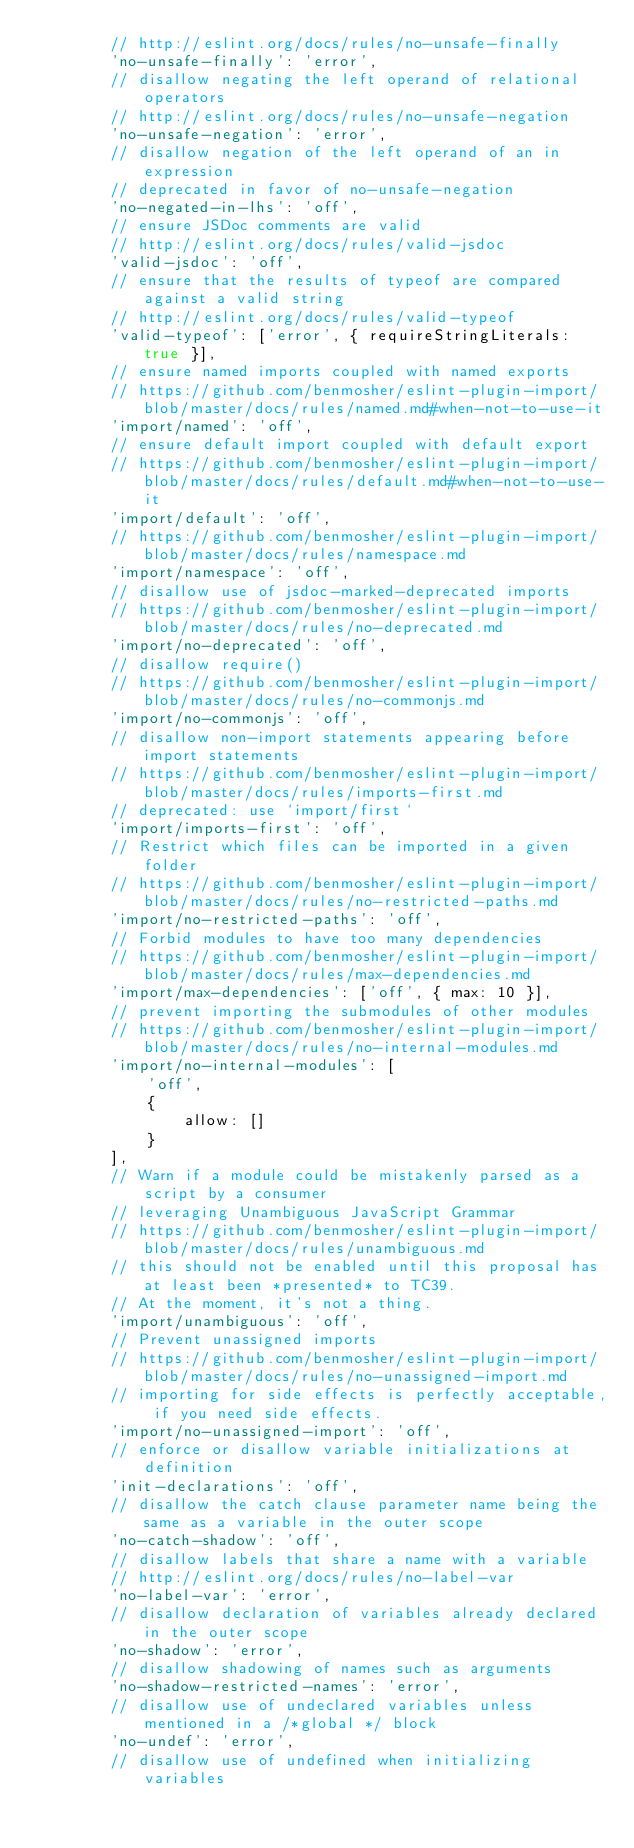<code> <loc_0><loc_0><loc_500><loc_500><_JavaScript_>        // http://eslint.org/docs/rules/no-unsafe-finally
        'no-unsafe-finally': 'error',
        // disallow negating the left operand of relational operators
        // http://eslint.org/docs/rules/no-unsafe-negation
        'no-unsafe-negation': 'error',
        // disallow negation of the left operand of an in expression
        // deprecated in favor of no-unsafe-negation
        'no-negated-in-lhs': 'off',
        // ensure JSDoc comments are valid
        // http://eslint.org/docs/rules/valid-jsdoc
        'valid-jsdoc': 'off',
        // ensure that the results of typeof are compared against a valid string
        // http://eslint.org/docs/rules/valid-typeof
        'valid-typeof': ['error', { requireStringLiterals: true }],
        // ensure named imports coupled with named exports
        // https://github.com/benmosher/eslint-plugin-import/blob/master/docs/rules/named.md#when-not-to-use-it
        'import/named': 'off',
        // ensure default import coupled with default export
        // https://github.com/benmosher/eslint-plugin-import/blob/master/docs/rules/default.md#when-not-to-use-it
        'import/default': 'off',
        // https://github.com/benmosher/eslint-plugin-import/blob/master/docs/rules/namespace.md
        'import/namespace': 'off',
        // disallow use of jsdoc-marked-deprecated imports
        // https://github.com/benmosher/eslint-plugin-import/blob/master/docs/rules/no-deprecated.md
        'import/no-deprecated': 'off',
        // disallow require()
        // https://github.com/benmosher/eslint-plugin-import/blob/master/docs/rules/no-commonjs.md
        'import/no-commonjs': 'off',
        // disallow non-import statements appearing before import statements
        // https://github.com/benmosher/eslint-plugin-import/blob/master/docs/rules/imports-first.md
        // deprecated: use `import/first`
        'import/imports-first': 'off',
        // Restrict which files can be imported in a given folder
        // https://github.com/benmosher/eslint-plugin-import/blob/master/docs/rules/no-restricted-paths.md
        'import/no-restricted-paths': 'off',
        // Forbid modules to have too many dependencies
        // https://github.com/benmosher/eslint-plugin-import/blob/master/docs/rules/max-dependencies.md
        'import/max-dependencies': ['off', { max: 10 }],
        // prevent importing the submodules of other modules
        // https://github.com/benmosher/eslint-plugin-import/blob/master/docs/rules/no-internal-modules.md
        'import/no-internal-modules': [
            'off',
            {
                allow: []
            }
        ],
        // Warn if a module could be mistakenly parsed as a script by a consumer
        // leveraging Unambiguous JavaScript Grammar
        // https://github.com/benmosher/eslint-plugin-import/blob/master/docs/rules/unambiguous.md
        // this should not be enabled until this proposal has at least been *presented* to TC39.
        // At the moment, it's not a thing.
        'import/unambiguous': 'off',
        // Prevent unassigned imports
        // https://github.com/benmosher/eslint-plugin-import/blob/master/docs/rules/no-unassigned-import.md
        // importing for side effects is perfectly acceptable, if you need side effects.
        'import/no-unassigned-import': 'off',
        // enforce or disallow variable initializations at definition
        'init-declarations': 'off',
        // disallow the catch clause parameter name being the same as a variable in the outer scope
        'no-catch-shadow': 'off',
        // disallow labels that share a name with a variable
        // http://eslint.org/docs/rules/no-label-var
        'no-label-var': 'error',
        // disallow declaration of variables already declared in the outer scope
        'no-shadow': 'error',
        // disallow shadowing of names such as arguments
        'no-shadow-restricted-names': 'error',
        // disallow use of undeclared variables unless mentioned in a /*global */ block
        'no-undef': 'error',
        // disallow use of undefined when initializing variables</code> 